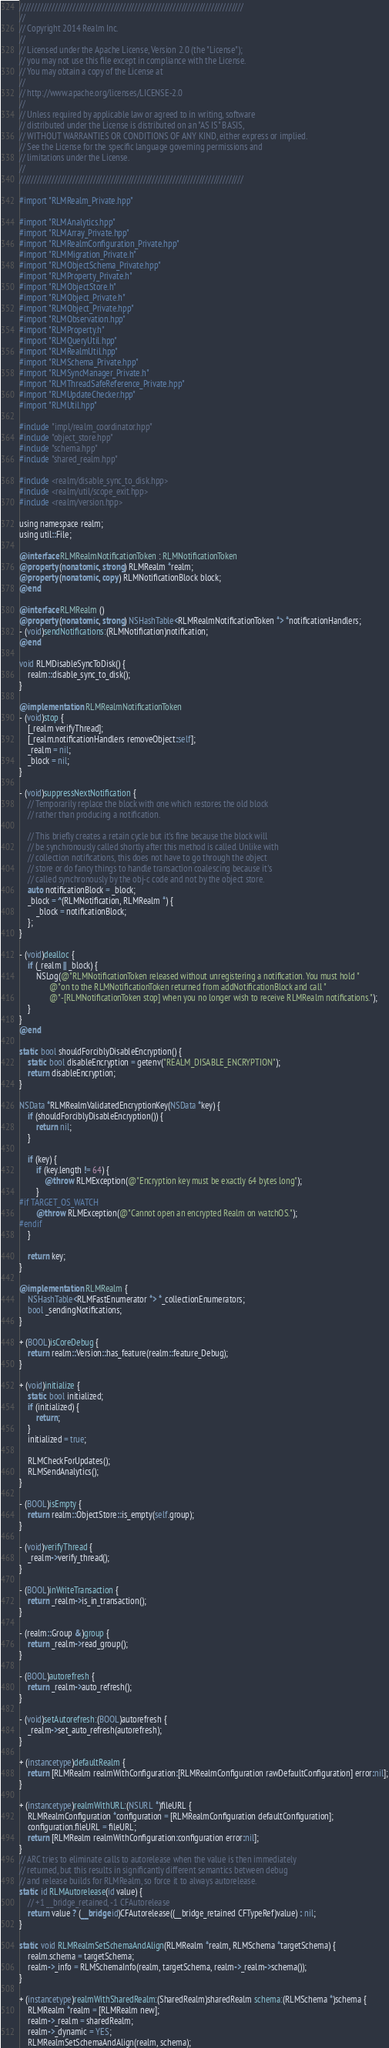<code> <loc_0><loc_0><loc_500><loc_500><_ObjectiveC_>////////////////////////////////////////////////////////////////////////////
//
// Copyright 2014 Realm Inc.
//
// Licensed under the Apache License, Version 2.0 (the "License");
// you may not use this file except in compliance with the License.
// You may obtain a copy of the License at
//
// http://www.apache.org/licenses/LICENSE-2.0
//
// Unless required by applicable law or agreed to in writing, software
// distributed under the License is distributed on an "AS IS" BASIS,
// WITHOUT WARRANTIES OR CONDITIONS OF ANY KIND, either express or implied.
// See the License for the specific language governing permissions and
// limitations under the License.
//
////////////////////////////////////////////////////////////////////////////

#import "RLMRealm_Private.hpp"

#import "RLMAnalytics.hpp"
#import "RLMArray_Private.hpp"
#import "RLMRealmConfiguration_Private.hpp"
#import "RLMMigration_Private.h"
#import "RLMObjectSchema_Private.hpp"
#import "RLMProperty_Private.h"
#import "RLMObjectStore.h"
#import "RLMObject_Private.h"
#import "RLMObject_Private.hpp"
#import "RLMObservation.hpp"
#import "RLMProperty.h"
#import "RLMQueryUtil.hpp"
#import "RLMRealmUtil.hpp"
#import "RLMSchema_Private.hpp"
#import "RLMSyncManager_Private.h"
#import "RLMThreadSafeReference_Private.hpp"
#import "RLMUpdateChecker.hpp"
#import "RLMUtil.hpp"

#include "impl/realm_coordinator.hpp"
#include "object_store.hpp"
#include "schema.hpp"
#include "shared_realm.hpp"

#include <realm/disable_sync_to_disk.hpp>
#include <realm/util/scope_exit.hpp>
#include <realm/version.hpp>

using namespace realm;
using util::File;

@interface RLMRealmNotificationToken : RLMNotificationToken
@property (nonatomic, strong) RLMRealm *realm;
@property (nonatomic, copy) RLMNotificationBlock block;
@end

@interface RLMRealm ()
@property (nonatomic, strong) NSHashTable<RLMRealmNotificationToken *> *notificationHandlers;
- (void)sendNotifications:(RLMNotification)notification;
@end

void RLMDisableSyncToDisk() {
    realm::disable_sync_to_disk();
}

@implementation RLMRealmNotificationToken
- (void)stop {
    [_realm verifyThread];
    [_realm.notificationHandlers removeObject:self];
    _realm = nil;
    _block = nil;
}

- (void)suppressNextNotification {
    // Temporarily replace the block with one which restores the old block
    // rather than producing a notification.

    // This briefly creates a retain cycle but it's fine because the block will
    // be synchronously called shortly after this method is called. Unlike with
    // collection notifications, this does not have to go through the object
    // store or do fancy things to handle transaction coalescing because it's
    // called synchronously by the obj-c code and not by the object store.
    auto notificationBlock = _block;
    _block = ^(RLMNotification, RLMRealm *) {
        _block = notificationBlock;
    };
}

- (void)dealloc {
    if (_realm || _block) {
        NSLog(@"RLMNotificationToken released without unregistering a notification. You must hold "
              @"on to the RLMNotificationToken returned from addNotificationBlock and call "
              @"-[RLMNotificationToken stop] when you no longer wish to receive RLMRealm notifications.");
    }
}
@end

static bool shouldForciblyDisableEncryption() {
    static bool disableEncryption = getenv("REALM_DISABLE_ENCRYPTION");
    return disableEncryption;
}

NSData *RLMRealmValidatedEncryptionKey(NSData *key) {
    if (shouldForciblyDisableEncryption()) {
        return nil;
    }

    if (key) {
        if (key.length != 64) {
            @throw RLMException(@"Encryption key must be exactly 64 bytes long");
        }
#if TARGET_OS_WATCH
        @throw RLMException(@"Cannot open an encrypted Realm on watchOS.");
#endif
    }

    return key;
}

@implementation RLMRealm {
    NSHashTable<RLMFastEnumerator *> *_collectionEnumerators;
    bool _sendingNotifications;
}

+ (BOOL)isCoreDebug {
    return realm::Version::has_feature(realm::feature_Debug);
}

+ (void)initialize {
    static bool initialized;
    if (initialized) {
        return;
    }
    initialized = true;

    RLMCheckForUpdates();
    RLMSendAnalytics();
}

- (BOOL)isEmpty {
    return realm::ObjectStore::is_empty(self.group);
}

- (void)verifyThread {
    _realm->verify_thread();
}

- (BOOL)inWriteTransaction {
    return _realm->is_in_transaction();
}

- (realm::Group &)group {
    return _realm->read_group();
}

- (BOOL)autorefresh {
    return _realm->auto_refresh();
}

- (void)setAutorefresh:(BOOL)autorefresh {
    _realm->set_auto_refresh(autorefresh);
}

+ (instancetype)defaultRealm {
    return [RLMRealm realmWithConfiguration:[RLMRealmConfiguration rawDefaultConfiguration] error:nil];
}

+ (instancetype)realmWithURL:(NSURL *)fileURL {
    RLMRealmConfiguration *configuration = [RLMRealmConfiguration defaultConfiguration];
    configuration.fileURL = fileURL;
    return [RLMRealm realmWithConfiguration:configuration error:nil];
}
// ARC tries to eliminate calls to autorelease when the value is then immediately
// returned, but this results in significantly different semantics between debug
// and release builds for RLMRealm, so force it to always autorelease.
static id RLMAutorelease(id value) {
    // +1 __bridge_retained, -1 CFAutorelease
    return value ? (__bridge id)CFAutorelease((__bridge_retained CFTypeRef)value) : nil;
}

static void RLMRealmSetSchemaAndAlign(RLMRealm *realm, RLMSchema *targetSchema) {
    realm.schema = targetSchema;
    realm->_info = RLMSchemaInfo(realm, targetSchema, realm->_realm->schema());
}

+ (instancetype)realmWithSharedRealm:(SharedRealm)sharedRealm schema:(RLMSchema *)schema {
    RLMRealm *realm = [RLMRealm new];
    realm->_realm = sharedRealm;
    realm->_dynamic = YES;
    RLMRealmSetSchemaAndAlign(realm, schema);</code> 